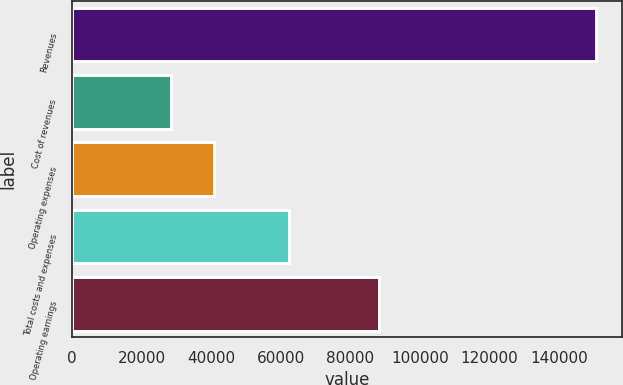Convert chart. <chart><loc_0><loc_0><loc_500><loc_500><bar_chart><fcel>Revenues<fcel>Cost of revenues<fcel>Operating expenses<fcel>Total costs and expenses<fcel>Operating earnings<nl><fcel>150694<fcel>28577<fcel>40788.7<fcel>62404<fcel>88290<nl></chart> 